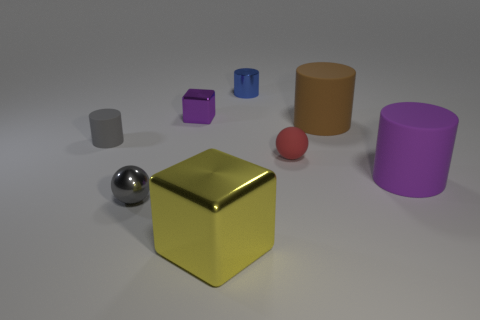Is there a blue shiny object that has the same size as the metallic ball?
Your answer should be compact. Yes. Are there the same number of brown cylinders left of the small block and big brown cylinders that are on the right side of the blue object?
Provide a succinct answer. No. Are there more small green shiny cylinders than large rubber objects?
Your response must be concise. No. How many rubber objects are either tiny gray cubes or yellow things?
Make the answer very short. 0. How many other tiny metal balls are the same color as the metal ball?
Offer a terse response. 0. There is a large object that is behind the rubber cylinder that is left of the big matte cylinder that is behind the large purple thing; what is its material?
Your answer should be compact. Rubber. There is a small shiny thing in front of the large cylinder that is behind the tiny gray matte cylinder; what color is it?
Give a very brief answer. Gray. What number of small things are either red things or yellow matte cubes?
Give a very brief answer. 1. What number of small blue cylinders are made of the same material as the tiny gray cylinder?
Provide a short and direct response. 0. There is a blue object that is to the left of the purple matte cylinder; how big is it?
Give a very brief answer. Small. 